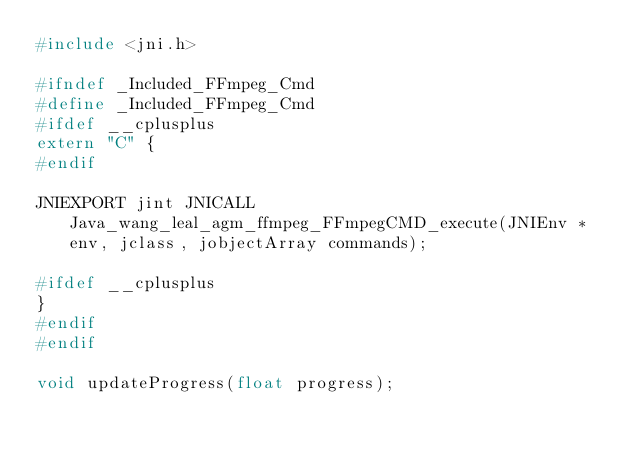Convert code to text. <code><loc_0><loc_0><loc_500><loc_500><_C_>#include <jni.h>

#ifndef _Included_FFmpeg_Cmd
#define _Included_FFmpeg_Cmd
#ifdef __cplusplus
extern "C" {
#endif

JNIEXPORT jint JNICALL Java_wang_leal_agm_ffmpeg_FFmpegCMD_execute(JNIEnv *env, jclass, jobjectArray commands);

#ifdef __cplusplus
}
#endif
#endif

void updateProgress(float progress);</code> 